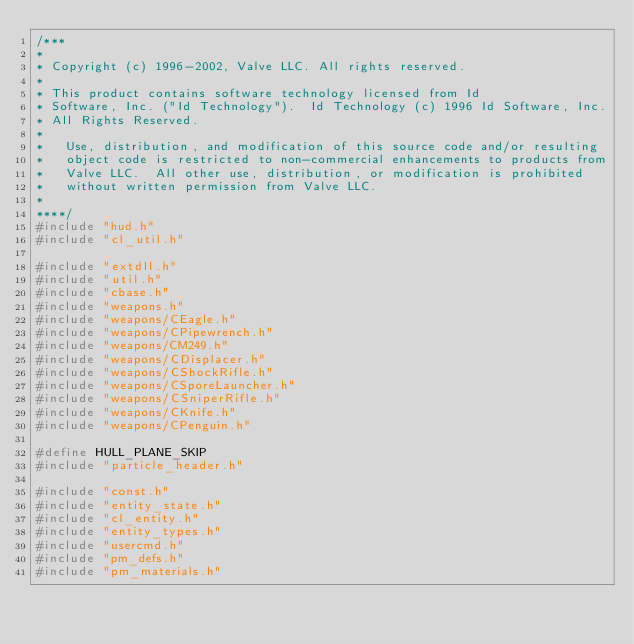Convert code to text. <code><loc_0><loc_0><loc_500><loc_500><_C++_>/***
*
*	Copyright (c) 1996-2002, Valve LLC. All rights reserved.
*	
*	This product contains software technology licensed from Id 
*	Software, Inc. ("Id Technology").  Id Technology (c) 1996 Id Software, Inc. 
*	All Rights Reserved.
*
*   Use, distribution, and modification of this source code and/or resulting
*   object code is restricted to non-commercial enhancements to products from
*   Valve LLC.  All other use, distribution, or modification is prohibited
*   without written permission from Valve LLC.
*
****/
#include "hud.h"
#include "cl_util.h"

#include "extdll.h"
#include "util.h"
#include "cbase.h"
#include "weapons.h"
#include "weapons/CEagle.h"
#include "weapons/CPipewrench.h"
#include "weapons/CM249.h"
#include "weapons/CDisplacer.h"
#include "weapons/CShockRifle.h"
#include "weapons/CSporeLauncher.h"
#include "weapons/CSniperRifle.h"
#include "weapons/CKnife.h"
#include "weapons/CPenguin.h"

#define HULL_PLANE_SKIP
#include "particle_header.h"

#include "const.h"
#include "entity_state.h"
#include "cl_entity.h"
#include "entity_types.h"
#include "usercmd.h"
#include "pm_defs.h"
#include "pm_materials.h"
</code> 